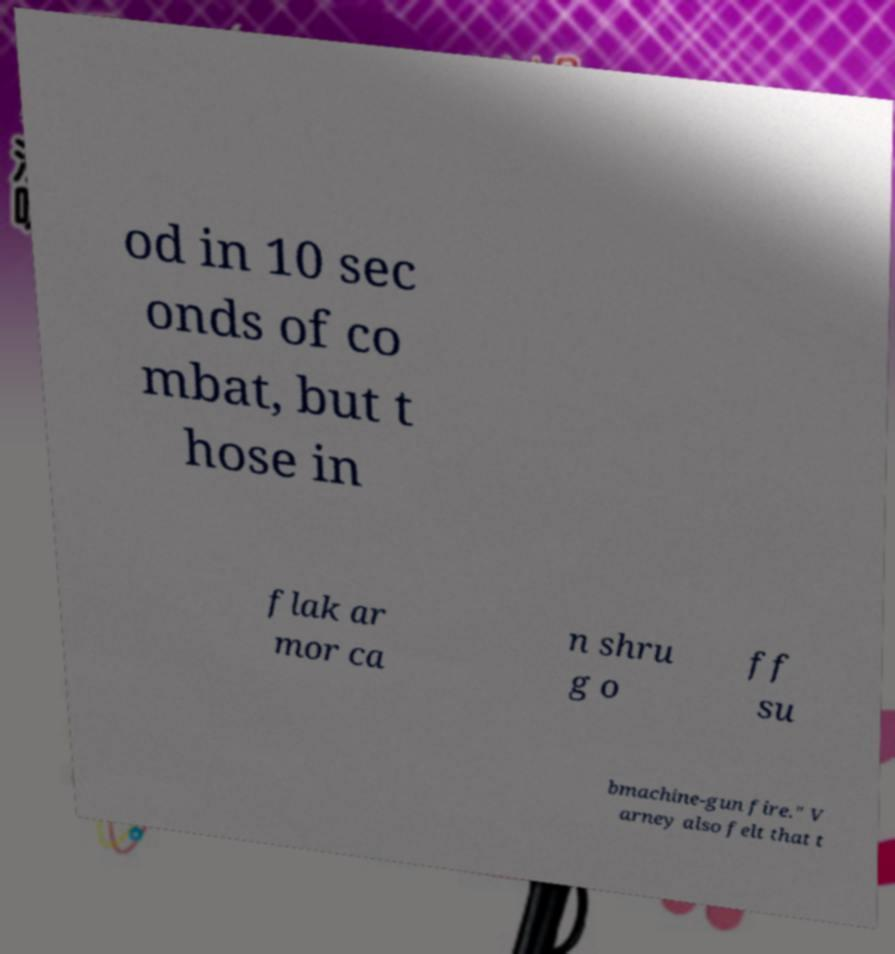Please read and relay the text visible in this image. What does it say? od in 10 sec onds of co mbat, but t hose in flak ar mor ca n shru g o ff su bmachine-gun fire." V arney also felt that t 